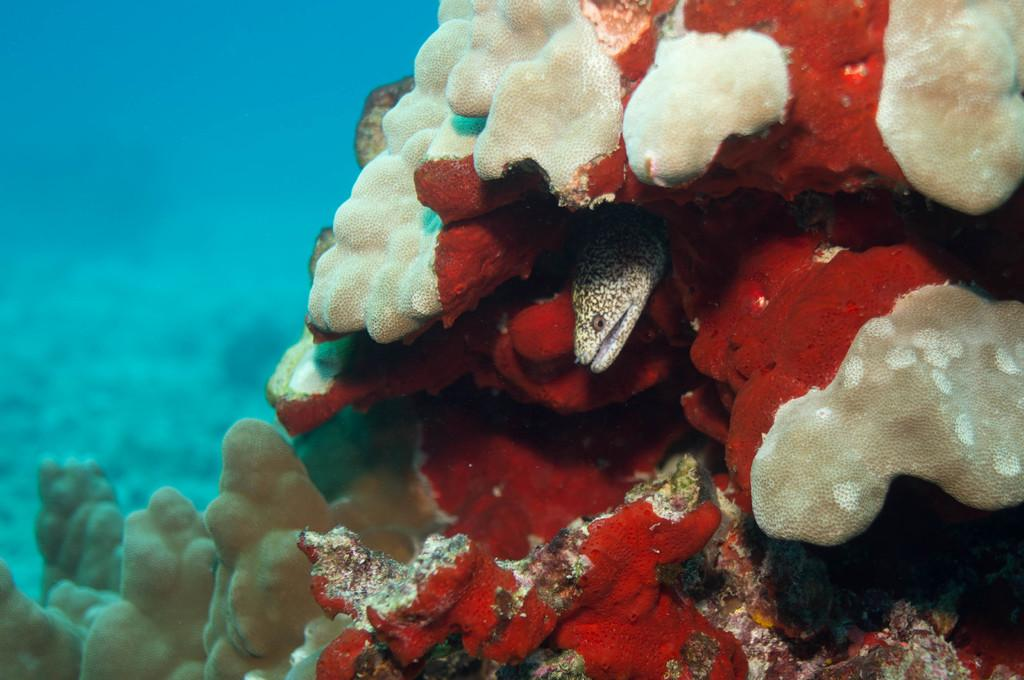What colors can be seen on the corals in the image? The corals in the image have white and red colors. What other marine life can be seen in the image? There is a fish in between the corals. What color is the background of the image? The background of the image is blue. What type of juice is being served in the image? There is no juice present in the image; it features corals and a fish in an underwater setting. How many scales can be seen on the fish in the image? The image does not provide a close-up view of the fish, so it is not possible to determine the number of scales on the fish. 